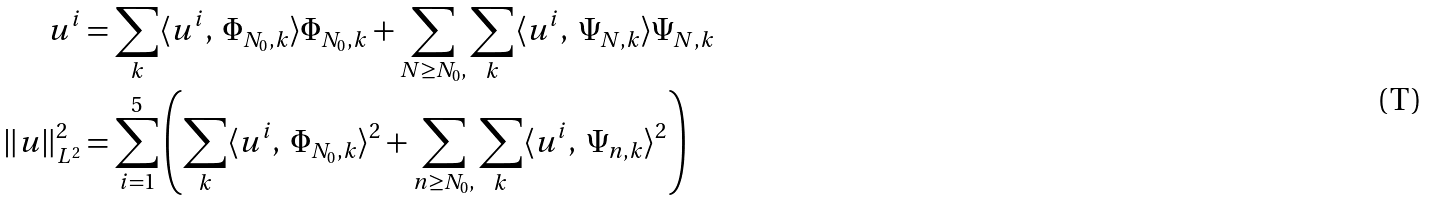<formula> <loc_0><loc_0><loc_500><loc_500>u ^ { i } & = \sum _ { k } \langle u ^ { i } , \ \Phi _ { N _ { 0 } , k } \rangle \Phi _ { N _ { 0 } , k } + \sum _ { N \geq N _ { 0 } , } \sum _ { k } \langle u ^ { i } , \ \Psi _ { N , k } \rangle \Psi _ { N , k } \\ \left \| u \right \| _ { L ^ { 2 } } ^ { 2 } & = \sum _ { i = 1 } ^ { 5 } \left ( \sum _ { k } \langle u ^ { i } , \ \Phi _ { N _ { 0 } , k } \rangle ^ { 2 } + \sum _ { n \geq N _ { 0 } , } \sum _ { k } \langle u ^ { i } , \ \Psi _ { n , k } \rangle ^ { 2 } \right )</formula> 